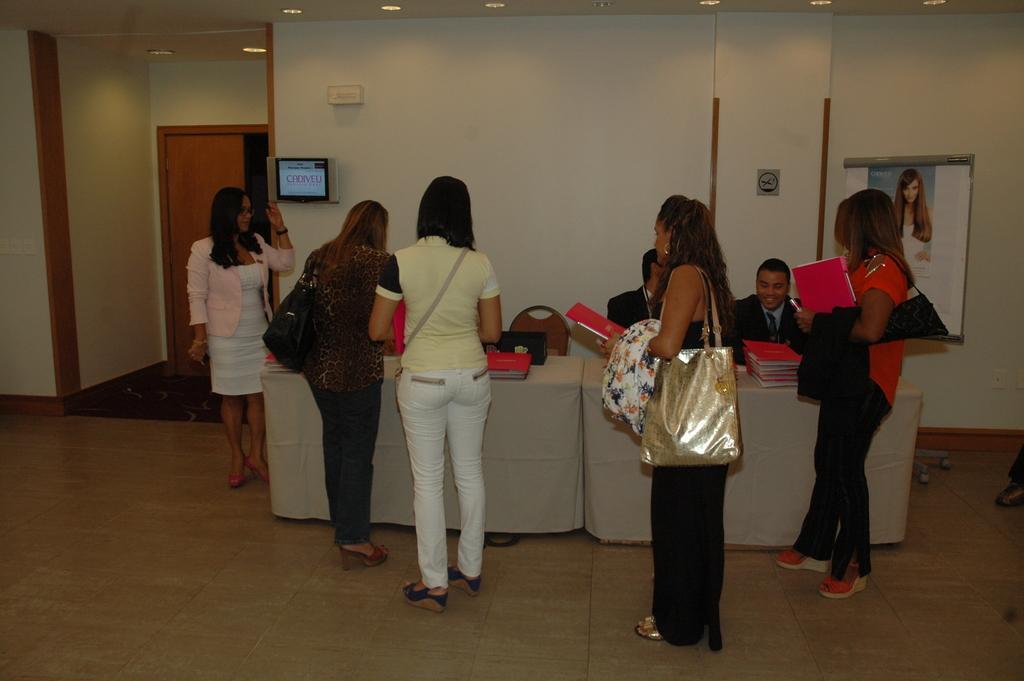Can you describe this image briefly? There are people standing and these two men sitting, we can see chair and these people are carrying bags. We can see books on tables. In the background we can see banner and screen on a wall and door. At the top we can see lights. 